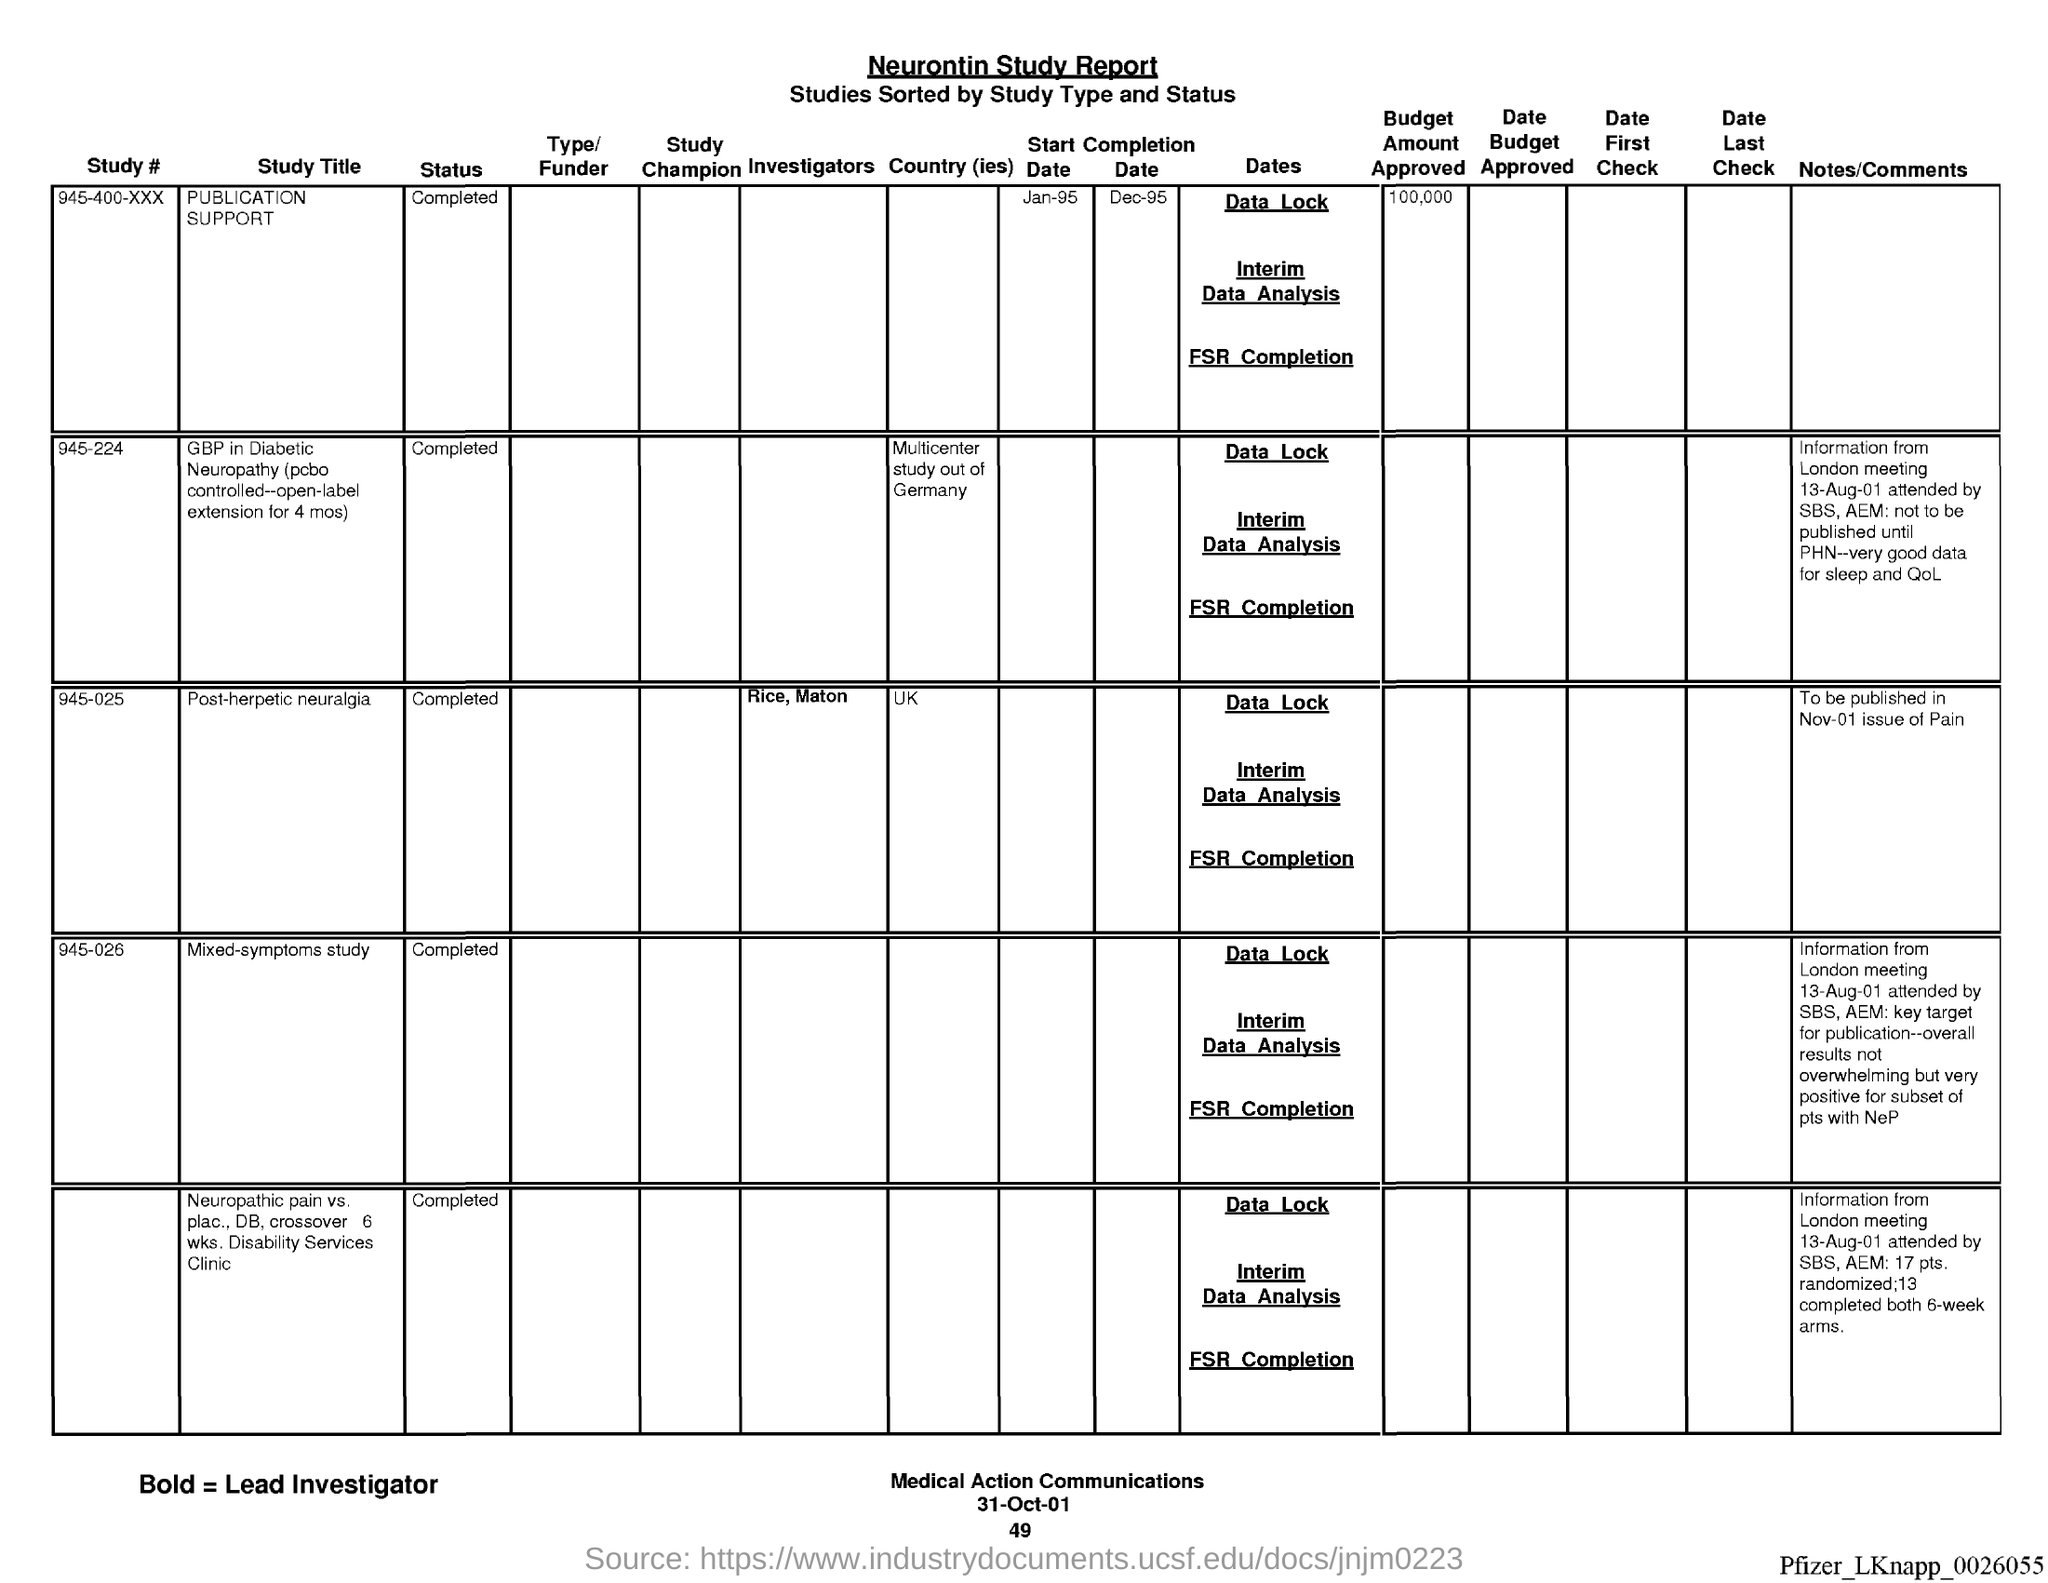Highlight a few significant elements in this photo. The date at the bottom of the page is 31st October 2001. The page number below the date is 49. The Neurontin Study report is the name of the report. 